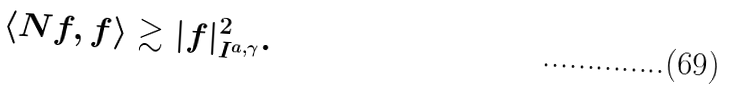<formula> <loc_0><loc_0><loc_500><loc_500>\langle N f , f \rangle \gtrsim | f | ^ { 2 } _ { I ^ { a , \gamma } } .</formula> 